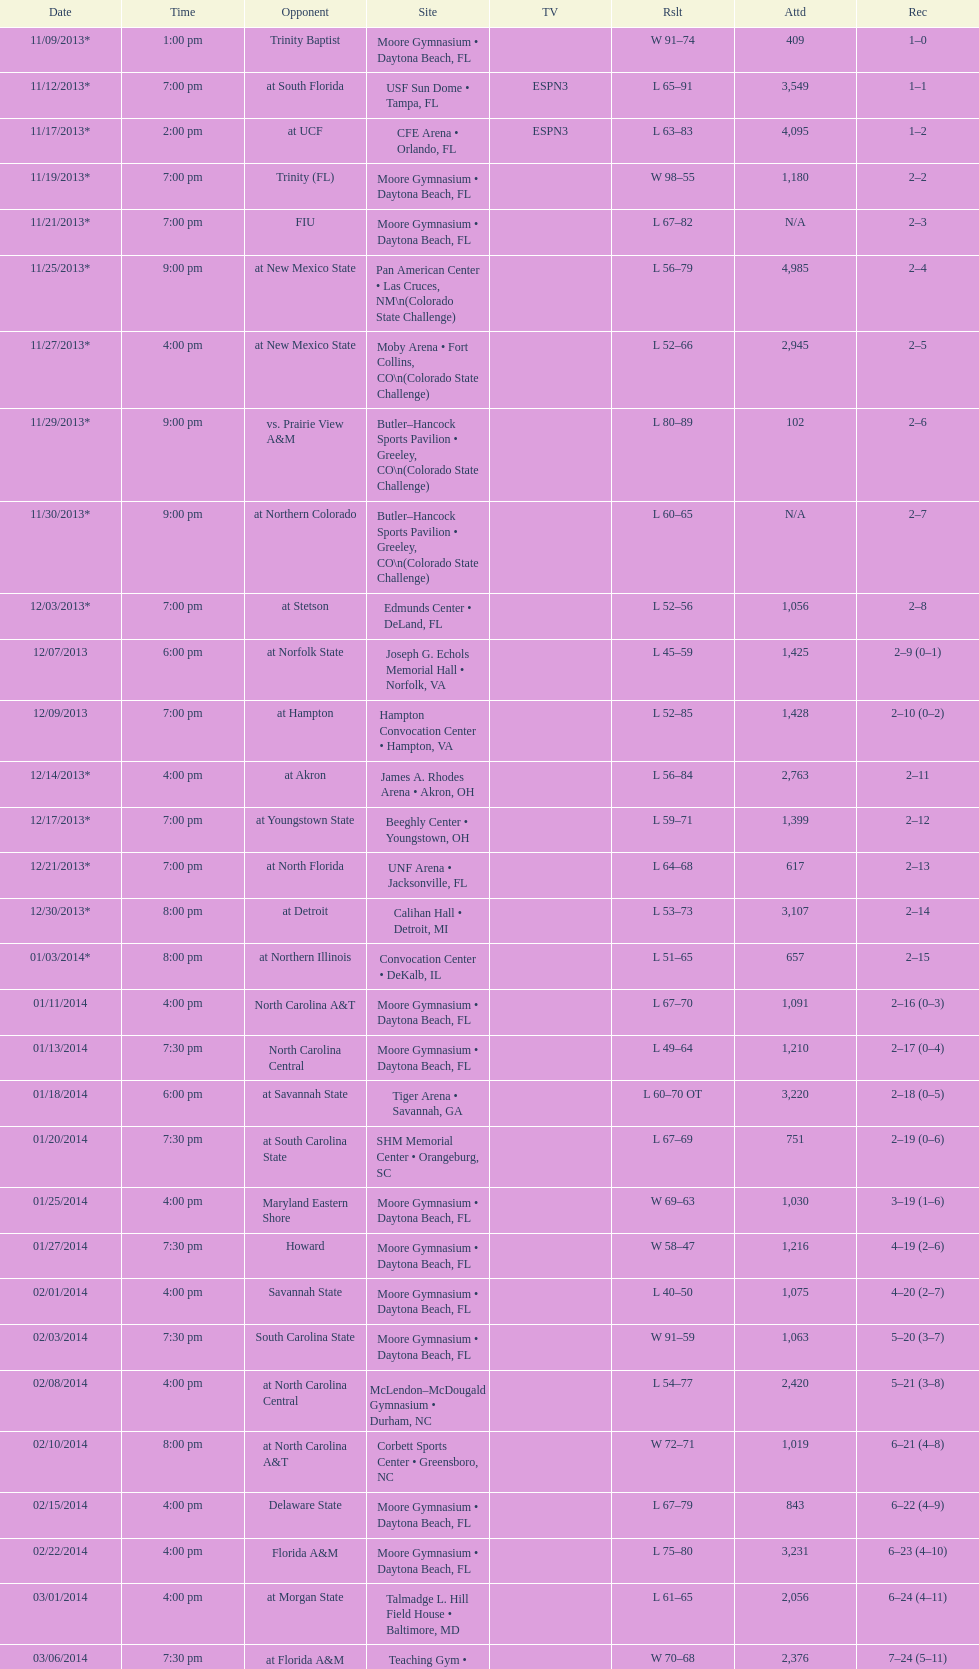Which game was later at night, fiu or northern colorado? Northern Colorado. 